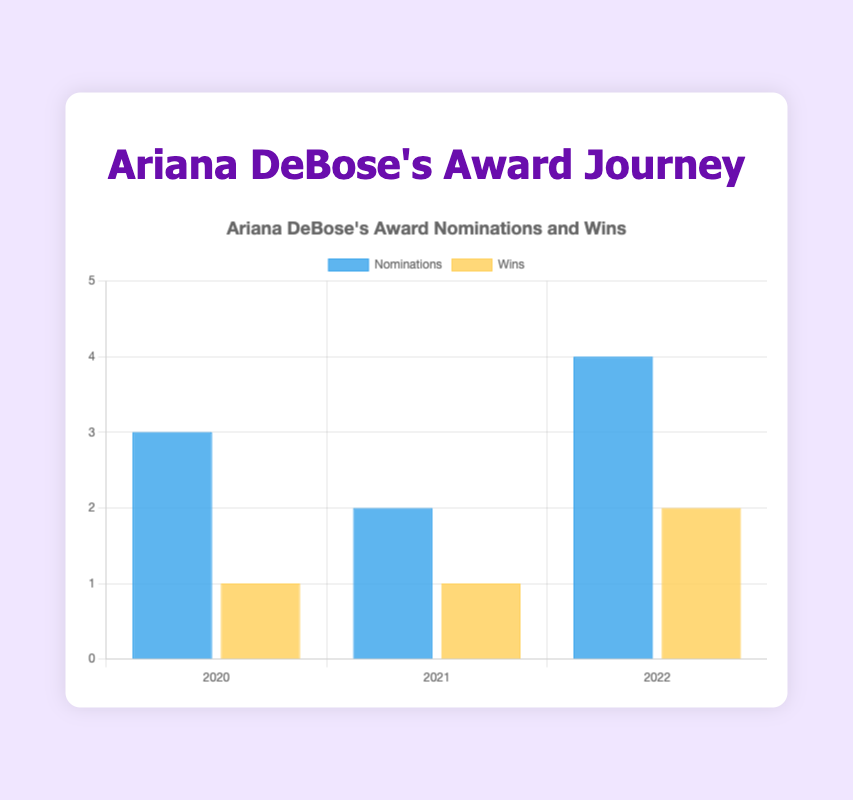what is the total number of nominations between 2020 and 2022? To find the total number of nominations, sum the nominations from each year: 3 (2020) + 2 (2021) + 4 (2022) = 9
Answer: 9 Which year had the highest number of wins? By checking each year's wins: 2020 had 1, 2021 had 1, and 2022 had 2. So, 2022 had the highest number of wins.
Answer: 2022 How many more wins are there in 2022 compared to 2020? Calculate the difference in wins between 2022 and 2020: 2 (2022) - 1 (2020) = 1
Answer: 1 What is the ratio of wins to nominations in 2021? The ratio can be calculated by dividing the number of wins by the number of nominations for 2021: 1 win / 2 nominations = 0.5
Answer: 0.5 In which year were the nominations and wins equal? By comparing the nominations and wins for each year: in 2021, both nominations and wins are the same (2 nominations and 1 win). None of the years fit this scenario.
Answer: None Among the years, which year has both the highest nominations and highest wins? Check the nominations and wins for each year: highest nominations in 2022 (4) and highest wins in 2022 (2).
Answer: 2022 Which year shows the greatest difference between nominations and wins? Calculate the difference between nominations and wins for each year: 
2020: 3 - 1 = 2, 
2021: 2 - 1 = 1, 
2022: 4 - 2 = 2.
Both 2020 and 2022 show a difference of 2.
Answer: 2020 and 2022 What percentage of the total nominations were won in 2022? To find the percentage, divide the wins by nominations for 2022, then multiply by 100: (2 wins / 4 nominations) * 100 = 50%
Answer: 50 How many bars represent the number of wins in the entire chart? By counting the number of years depicted, which also represent the bars for wins: There are 3 years, thus 3 bars for wins.
Answer: 3 